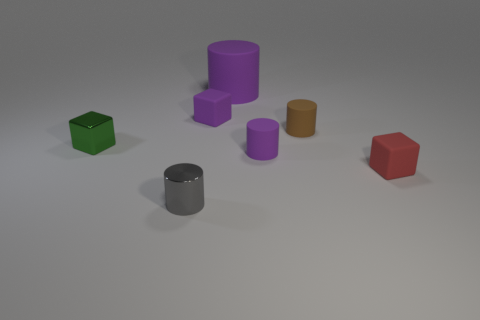Subtract 1 cylinders. How many cylinders are left? 3 Add 1 tiny brown metallic balls. How many objects exist? 8 Subtract all cylinders. How many objects are left? 3 Subtract 0 yellow balls. How many objects are left? 7 Subtract all small metal blocks. Subtract all purple cylinders. How many objects are left? 4 Add 1 tiny purple matte objects. How many tiny purple matte objects are left? 3 Add 2 small shiny things. How many small shiny things exist? 4 